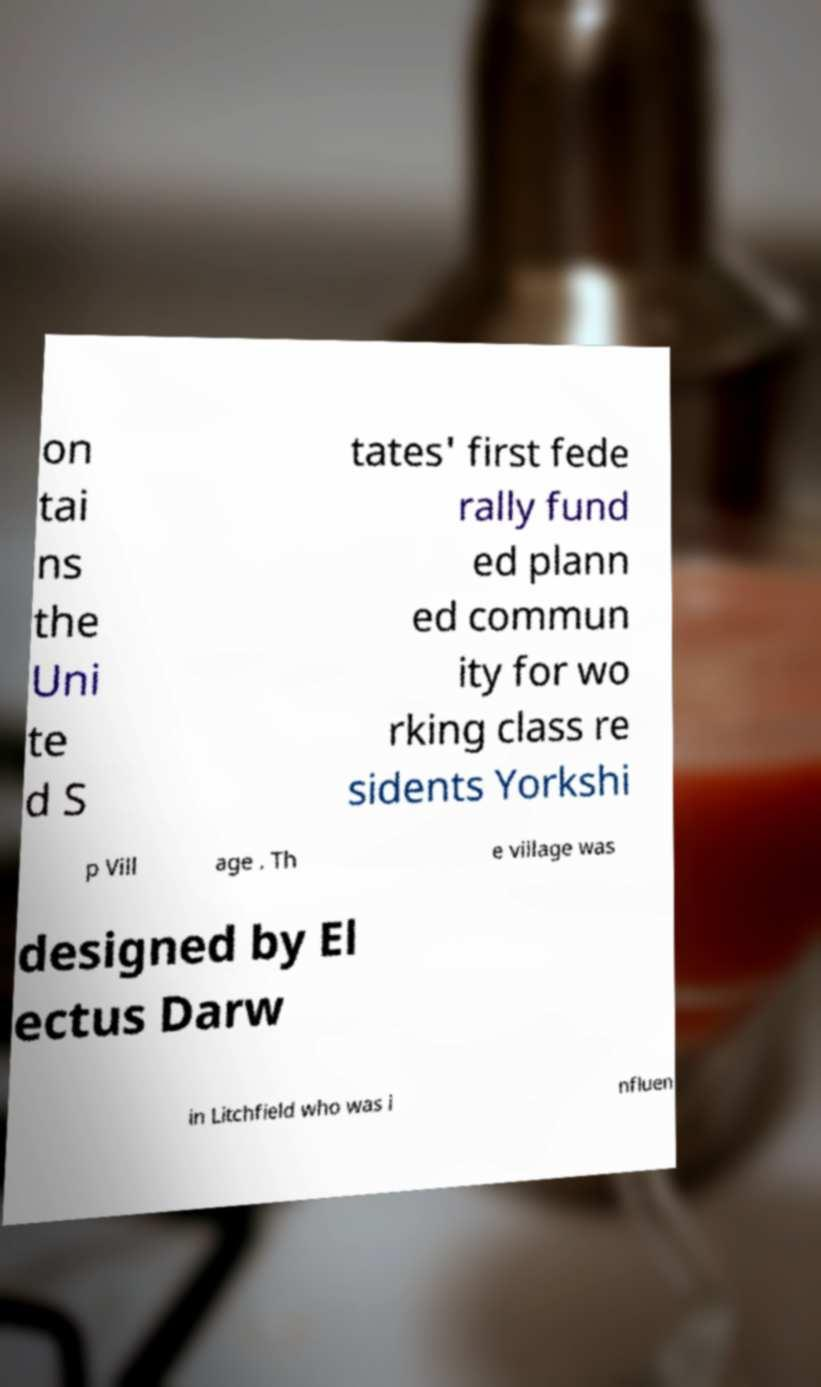I need the written content from this picture converted into text. Can you do that? on tai ns the Uni te d S tates' first fede rally fund ed plann ed commun ity for wo rking class re sidents Yorkshi p Vill age . Th e village was designed by El ectus Darw in Litchfield who was i nfluen 